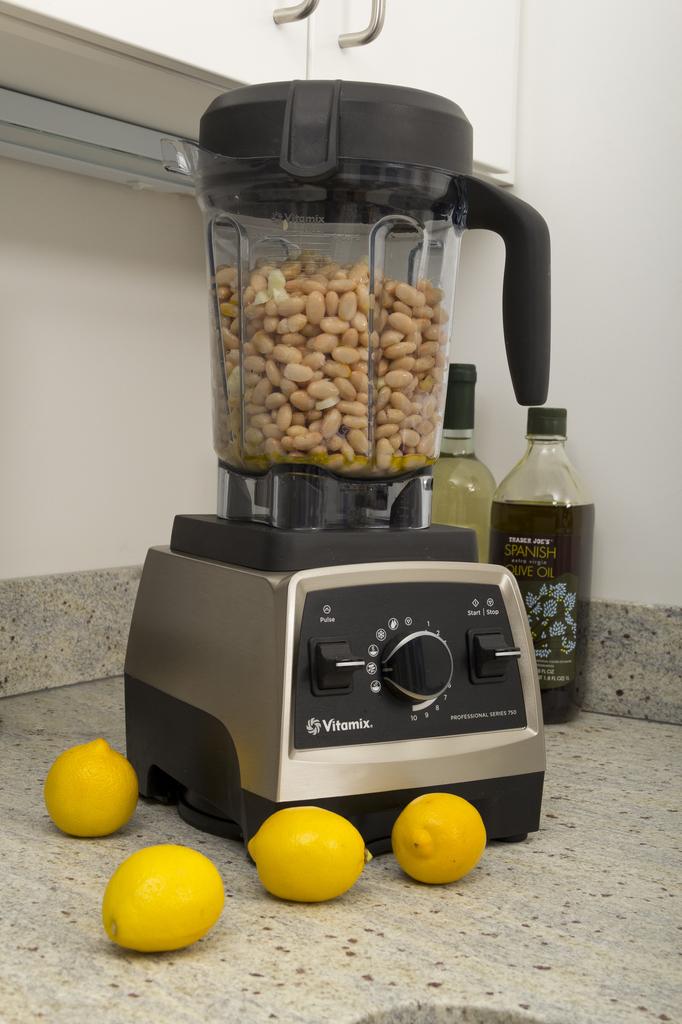What is the brand of the mixer?
Ensure brevity in your answer.  Vitamix. 